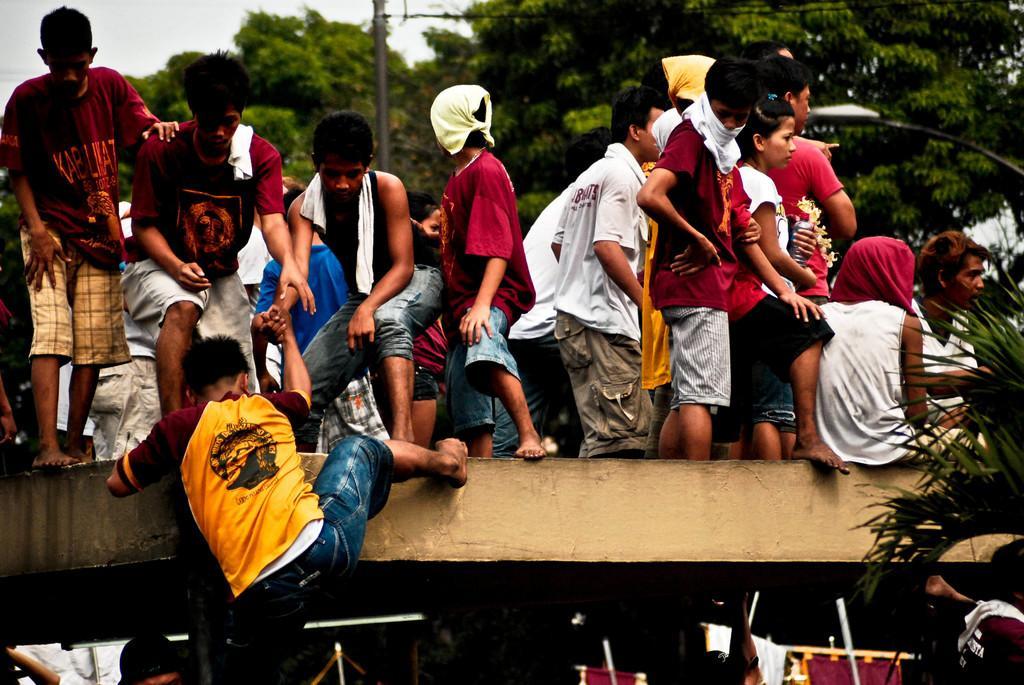Can you describe this image briefly? In this image I can see few people are standing and one person is climbing onto the bridge. In the background there are trees and light poles. At the bottom also there are few people. 